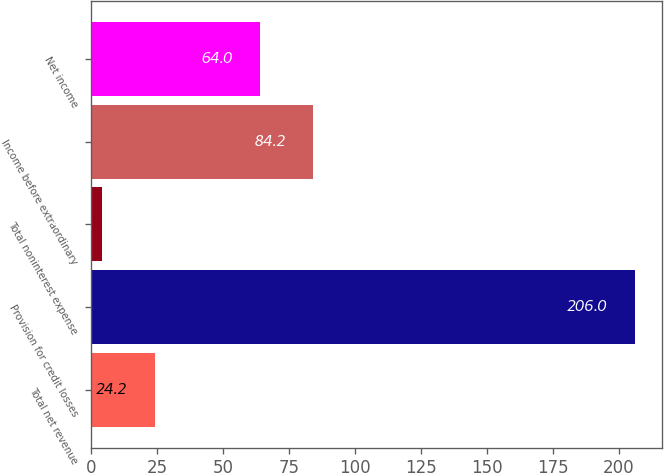<chart> <loc_0><loc_0><loc_500><loc_500><bar_chart><fcel>Total net revenue<fcel>Provision for credit losses<fcel>Total noninterest expense<fcel>Income before extraordinary<fcel>Net income<nl><fcel>24.2<fcel>206<fcel>4<fcel>84.2<fcel>64<nl></chart> 